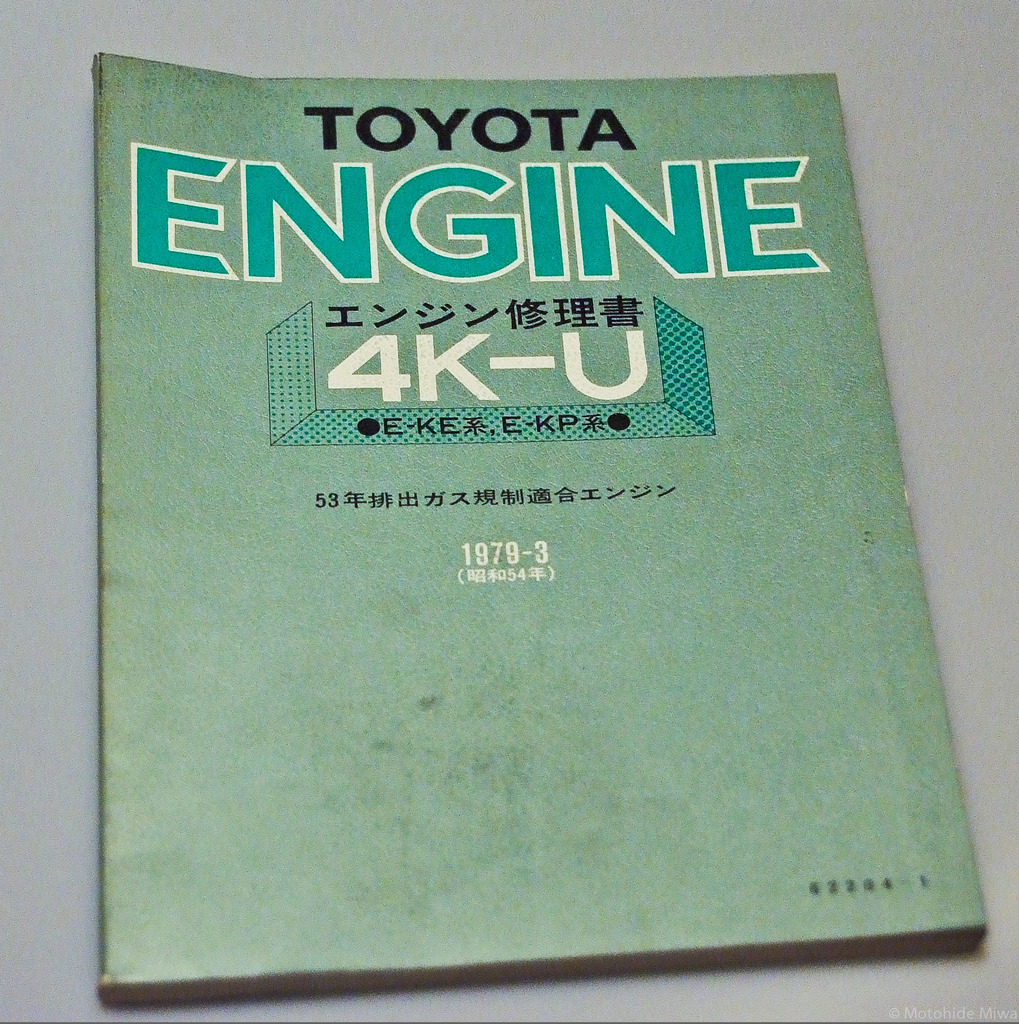Can you elaborate on the elements of the picture provided? The image displays a vintage 1979 Toyota Engine repair manual for the 4K-U model. The manual’s cover, primarily in a vivid teal hue, features text in contrasting white and black. It's specifically geared towards the models KE3#, KE6#, and KP6#. The manual was published in March 1979, indicated by '1979-3' on the cover, and is written in Japanese. It reads: 'TOYOTA ENGINE, エンジン修理書, 4K-U, 1979-3, 53年式 KE3#・KE6#・KP6#,' and this symbol '(4K-U型)' specifying the engine type as 4K-U. The book shows evident signs of use, perhaps hinting at its practical applications and value to owners of vehicles with the 4K-U engine. This particular engine was known for its reliability and efficiency during that era, marking an important contribution to Toyota's engine technology advancements. 